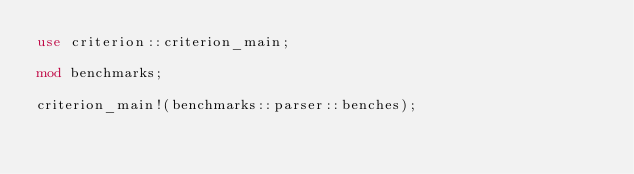<code> <loc_0><loc_0><loc_500><loc_500><_Rust_>use criterion::criterion_main;

mod benchmarks;

criterion_main!(benchmarks::parser::benches);
</code> 